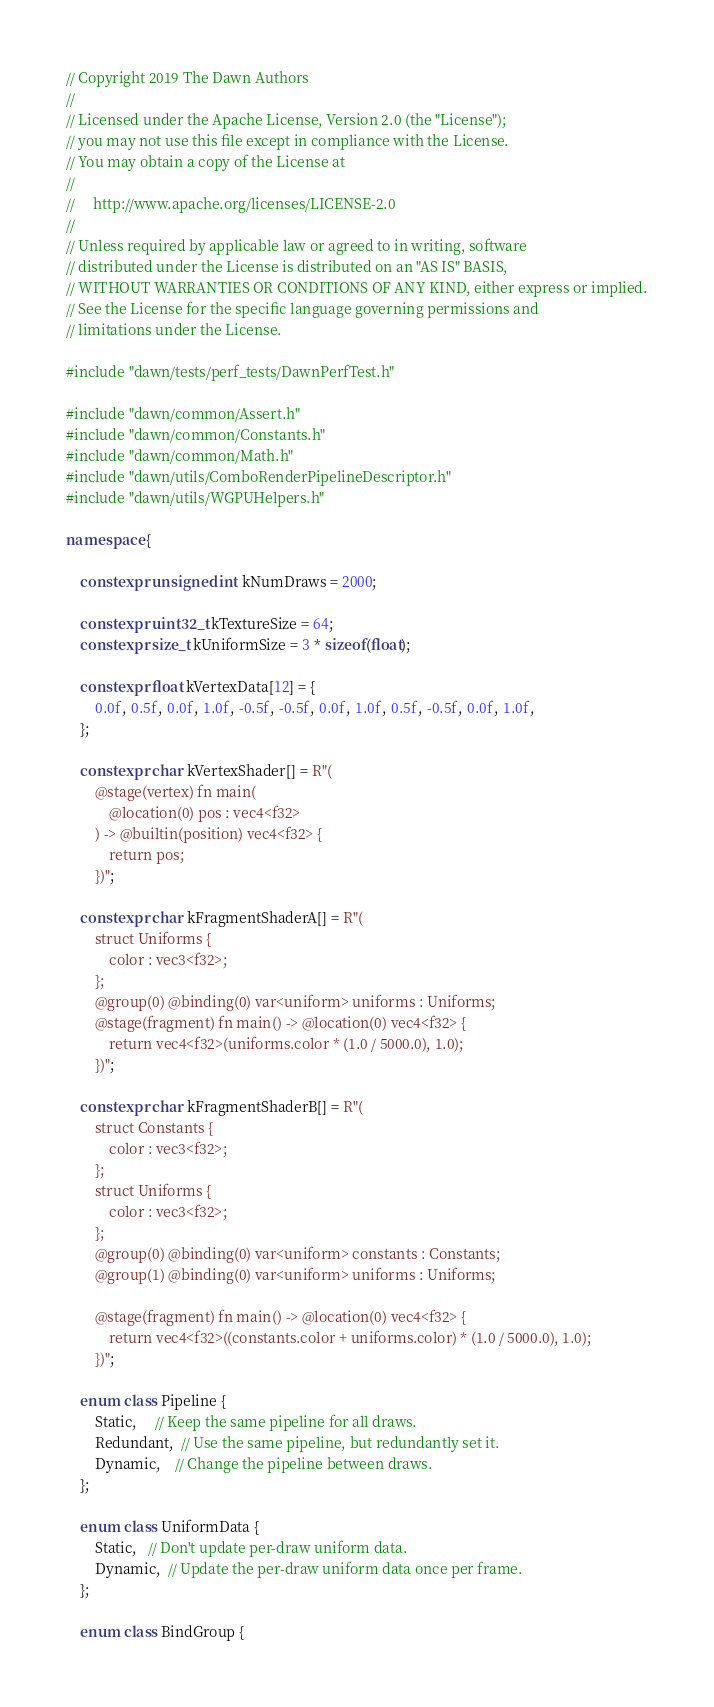Convert code to text. <code><loc_0><loc_0><loc_500><loc_500><_C++_>// Copyright 2019 The Dawn Authors
//
// Licensed under the Apache License, Version 2.0 (the "License");
// you may not use this file except in compliance with the License.
// You may obtain a copy of the License at
//
//     http://www.apache.org/licenses/LICENSE-2.0
//
// Unless required by applicable law or agreed to in writing, software
// distributed under the License is distributed on an "AS IS" BASIS,
// WITHOUT WARRANTIES OR CONDITIONS OF ANY KIND, either express or implied.
// See the License for the specific language governing permissions and
// limitations under the License.

#include "dawn/tests/perf_tests/DawnPerfTest.h"

#include "dawn/common/Assert.h"
#include "dawn/common/Constants.h"
#include "dawn/common/Math.h"
#include "dawn/utils/ComboRenderPipelineDescriptor.h"
#include "dawn/utils/WGPUHelpers.h"

namespace {

    constexpr unsigned int kNumDraws = 2000;

    constexpr uint32_t kTextureSize = 64;
    constexpr size_t kUniformSize = 3 * sizeof(float);

    constexpr float kVertexData[12] = {
        0.0f, 0.5f, 0.0f, 1.0f, -0.5f, -0.5f, 0.0f, 1.0f, 0.5f, -0.5f, 0.0f, 1.0f,
    };

    constexpr char kVertexShader[] = R"(
        @stage(vertex) fn main(
            @location(0) pos : vec4<f32>
        ) -> @builtin(position) vec4<f32> {
            return pos;
        })";

    constexpr char kFragmentShaderA[] = R"(
        struct Uniforms {
            color : vec3<f32>;
        };
        @group(0) @binding(0) var<uniform> uniforms : Uniforms;
        @stage(fragment) fn main() -> @location(0) vec4<f32> {
            return vec4<f32>(uniforms.color * (1.0 / 5000.0), 1.0);
        })";

    constexpr char kFragmentShaderB[] = R"(
        struct Constants {
            color : vec3<f32>;
        };
        struct Uniforms {
            color : vec3<f32>;
        };
        @group(0) @binding(0) var<uniform> constants : Constants;
        @group(1) @binding(0) var<uniform> uniforms : Uniforms;

        @stage(fragment) fn main() -> @location(0) vec4<f32> {
            return vec4<f32>((constants.color + uniforms.color) * (1.0 / 5000.0), 1.0);
        })";

    enum class Pipeline {
        Static,     // Keep the same pipeline for all draws.
        Redundant,  // Use the same pipeline, but redundantly set it.
        Dynamic,    // Change the pipeline between draws.
    };

    enum class UniformData {
        Static,   // Don't update per-draw uniform data.
        Dynamic,  // Update the per-draw uniform data once per frame.
    };

    enum class BindGroup {</code> 